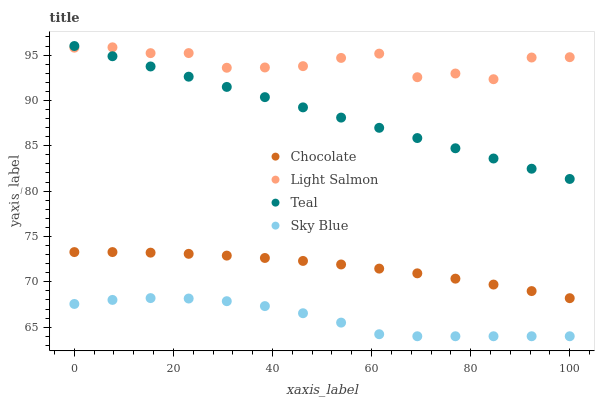Does Sky Blue have the minimum area under the curve?
Answer yes or no. Yes. Does Light Salmon have the maximum area under the curve?
Answer yes or no. Yes. Does Teal have the minimum area under the curve?
Answer yes or no. No. Does Teal have the maximum area under the curve?
Answer yes or no. No. Is Teal the smoothest?
Answer yes or no. Yes. Is Light Salmon the roughest?
Answer yes or no. Yes. Is Light Salmon the smoothest?
Answer yes or no. No. Is Teal the roughest?
Answer yes or no. No. Does Sky Blue have the lowest value?
Answer yes or no. Yes. Does Teal have the lowest value?
Answer yes or no. No. Does Teal have the highest value?
Answer yes or no. Yes. Does Light Salmon have the highest value?
Answer yes or no. No. Is Sky Blue less than Chocolate?
Answer yes or no. Yes. Is Light Salmon greater than Chocolate?
Answer yes or no. Yes. Does Teal intersect Light Salmon?
Answer yes or no. Yes. Is Teal less than Light Salmon?
Answer yes or no. No. Is Teal greater than Light Salmon?
Answer yes or no. No. Does Sky Blue intersect Chocolate?
Answer yes or no. No. 